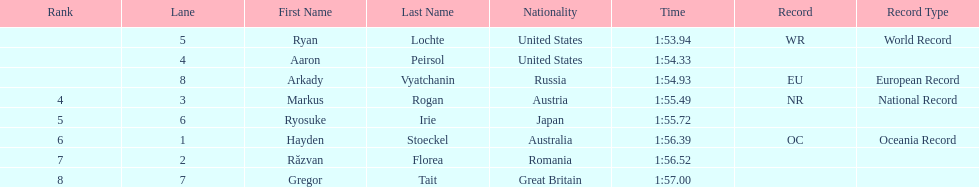Does russia or japan have the longer time? Japan. 